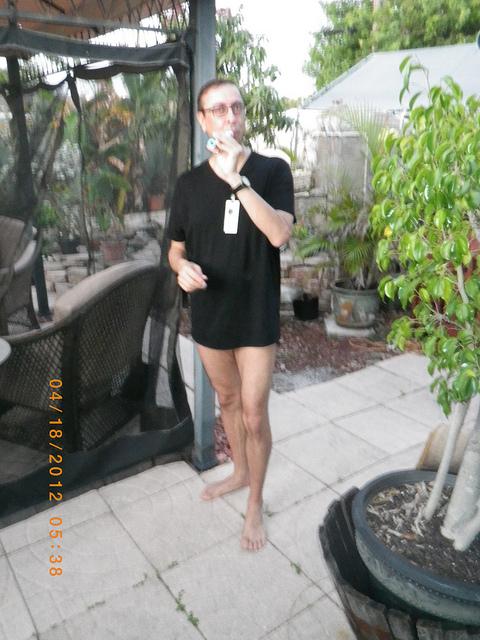Is this person wearing pants?
Give a very brief answer. No. What is the person holding?
Write a very short answer. Pipe. What color is his shirt?
Quick response, please. Black. Is he eating?
Give a very brief answer. Yes. 